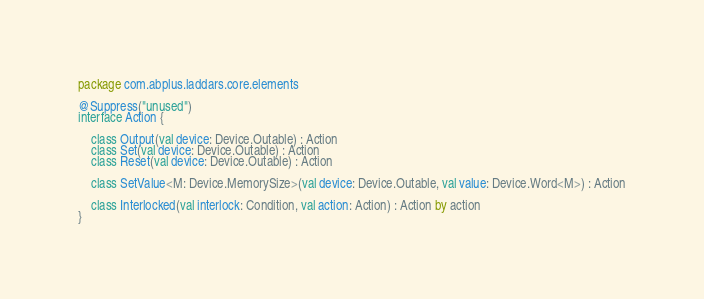Convert code to text. <code><loc_0><loc_0><loc_500><loc_500><_Kotlin_>package com.abplus.laddars.core.elements

@Suppress("unused")
interface Action {

    class Output(val device: Device.Outable) : Action
    class Set(val device: Device.Outable) : Action
    class Reset(val device: Device.Outable) : Action

    class SetValue<M: Device.MemorySize>(val device: Device.Outable, val value: Device.Word<M>) : Action

    class Interlocked(val interlock: Condition, val action: Action) : Action by action
}
</code> 